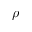Convert formula to latex. <formula><loc_0><loc_0><loc_500><loc_500>\rho</formula> 